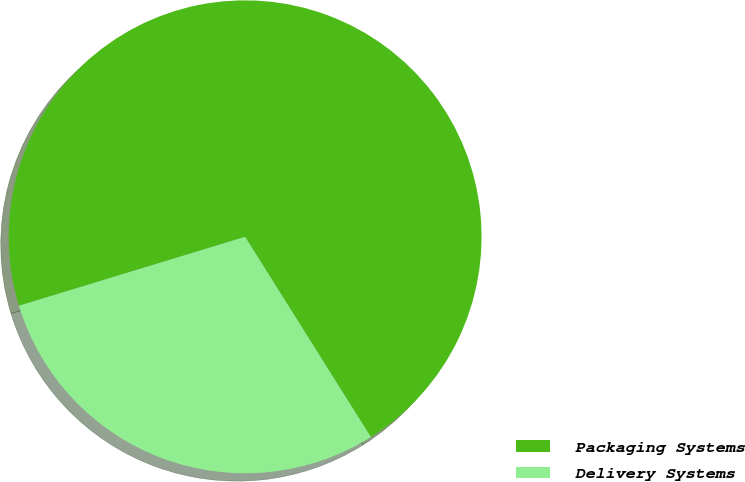Convert chart to OTSL. <chart><loc_0><loc_0><loc_500><loc_500><pie_chart><fcel>Packaging Systems<fcel>Delivery Systems<nl><fcel>70.78%<fcel>29.22%<nl></chart> 